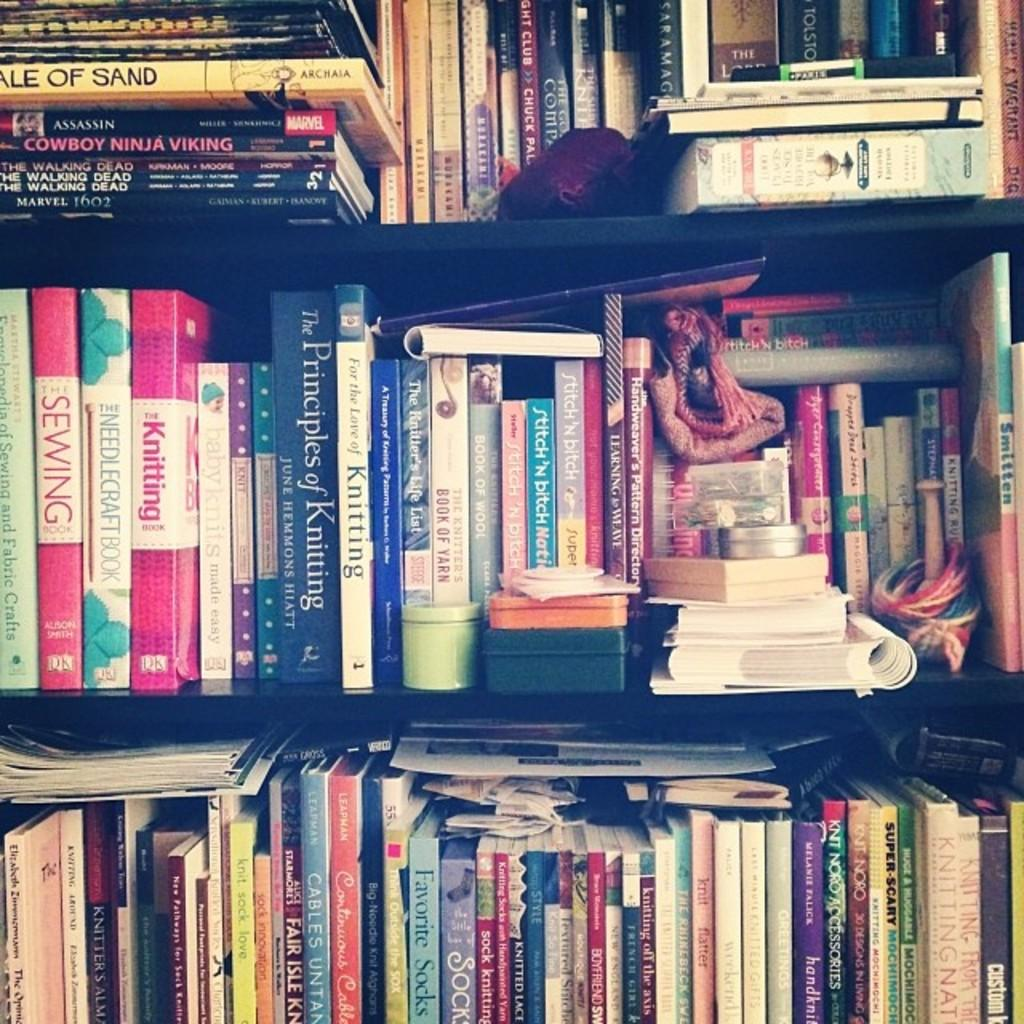What type of items can be seen in the image? There are books and objects in the racks in the image. Can you describe the books in the image? The books in the image are likely for reading or reference purposes. What can be inferred about the objects in the racks? The objects in the racks may be related to the books or serve as decoration or storage. Can you see a squirrel holding a bag and a cord in the image? No, there is no squirrel, bag, or cord present in the image. 